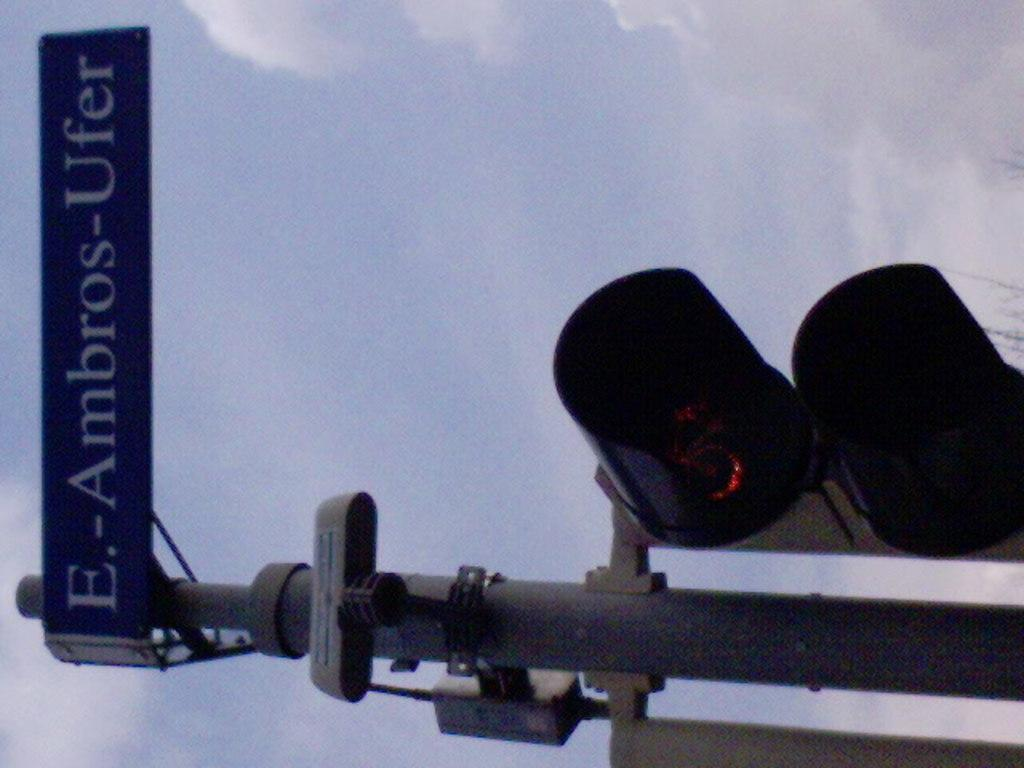What is the main object in the image? There is a traffic signal in the image. What else can be seen attached to a pole in the image? There is a board attached to a pole in the image. What is the color of the sky in the background? The sky in the background appears to be white in color. What type of suit is the teacher wearing while saying good-bye to the students in the image? There is no teacher, students, or suit present in the image. 